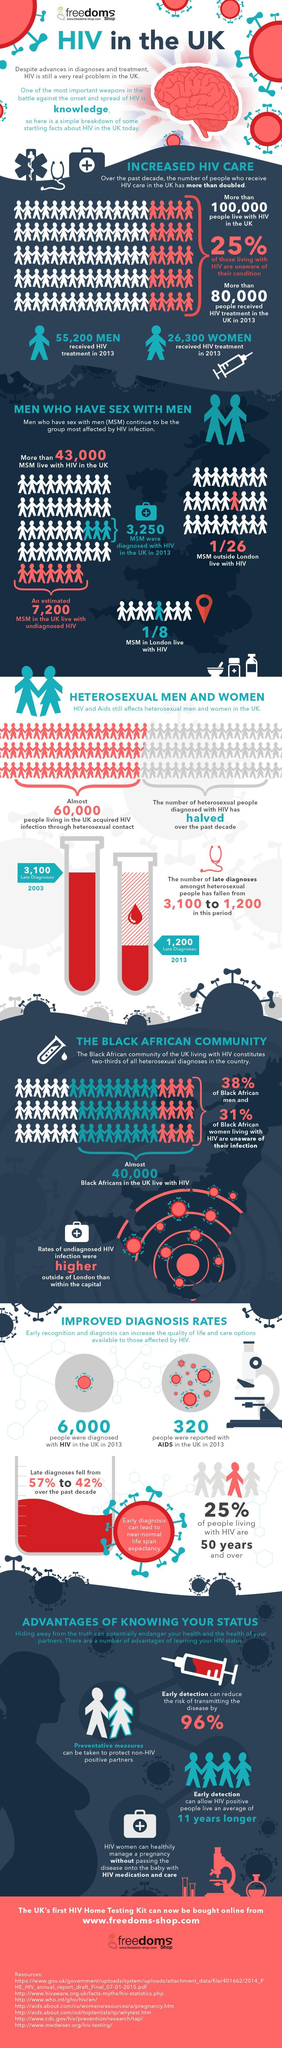How much late diagnosis of HIV/AIDS has been improved in the last 10 years?
Answer the question with a short phrase. 15 If taken a sample of 8 MSM in London, how many MSM are not HIV positive ? 7 What percentage of people living with HIV are not 50+? 75 If taken a sample of 26 MSM outside London, how many MSM are not HIV positive ? 25 How many people were confirmed with HIV in United Kingdom in 2013? 6,000 How many people were confirmed with AIDS in United Kingdom in 2013? 320 How much the number of late diagnosis has been reduced from 2003 to 2013? 1900 What percentage of HIV patients in UK are aware about their condition? 75 